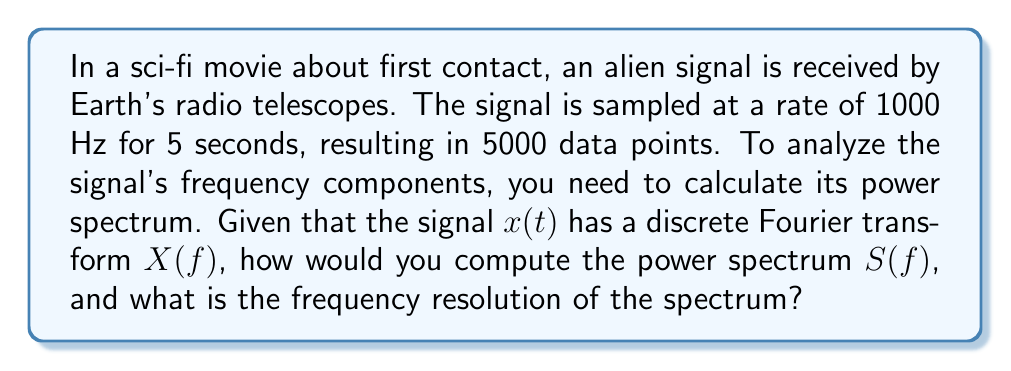Give your solution to this math problem. To calculate the power spectrum of the alien signal and determine its frequency resolution, we'll follow these steps:

1) The power spectrum $S(f)$ is defined as the squared magnitude of the Fourier transform:

   $$S(f) = |X(f)|^2$$

2) To compute $X(f)$, we would use the Discrete Fourier Transform (DFT) or its fast implementation, the Fast Fourier Transform (FFT).

3) The frequency resolution $\Delta f$ is determined by the total duration of the signal $T$:

   $$\Delta f = \frac{1}{T}$$

4) In this case:
   - Sampling rate: $f_s = 1000$ Hz
   - Duration: $T = 5$ seconds
   - Number of samples: $N = 5000$

5) Therefore, the frequency resolution is:

   $$\Delta f = \frac{1}{T} = \frac{1}{5 \text{ s}} = 0.2 \text{ Hz}$$

6) The power spectrum would be computed for frequencies from 0 Hz up to the Nyquist frequency $(f_s/2 = 500 \text{ Hz})$, with a resolution of 0.2 Hz.

7) In a practical implementation, you would:
   a) Apply a window function to the time-domain signal to reduce spectral leakage
   b) Compute the FFT of the windowed signal
   c) Calculate the squared magnitude of the FFT result
   d) Normalize the result by the square of the sum of the window function values

This process would reveal the frequency components of the alien signal, potentially uncovering patterns or modulations that could be key to decoding the extraterrestrial message.
Answer: The power spectrum $S(f)$ is computed as $S(f) = |X(f)|^2$, where $X(f)$ is the Discrete Fourier Transform of the signal. The frequency resolution of the spectrum is $\Delta f = 0.2 \text{ Hz}$. 